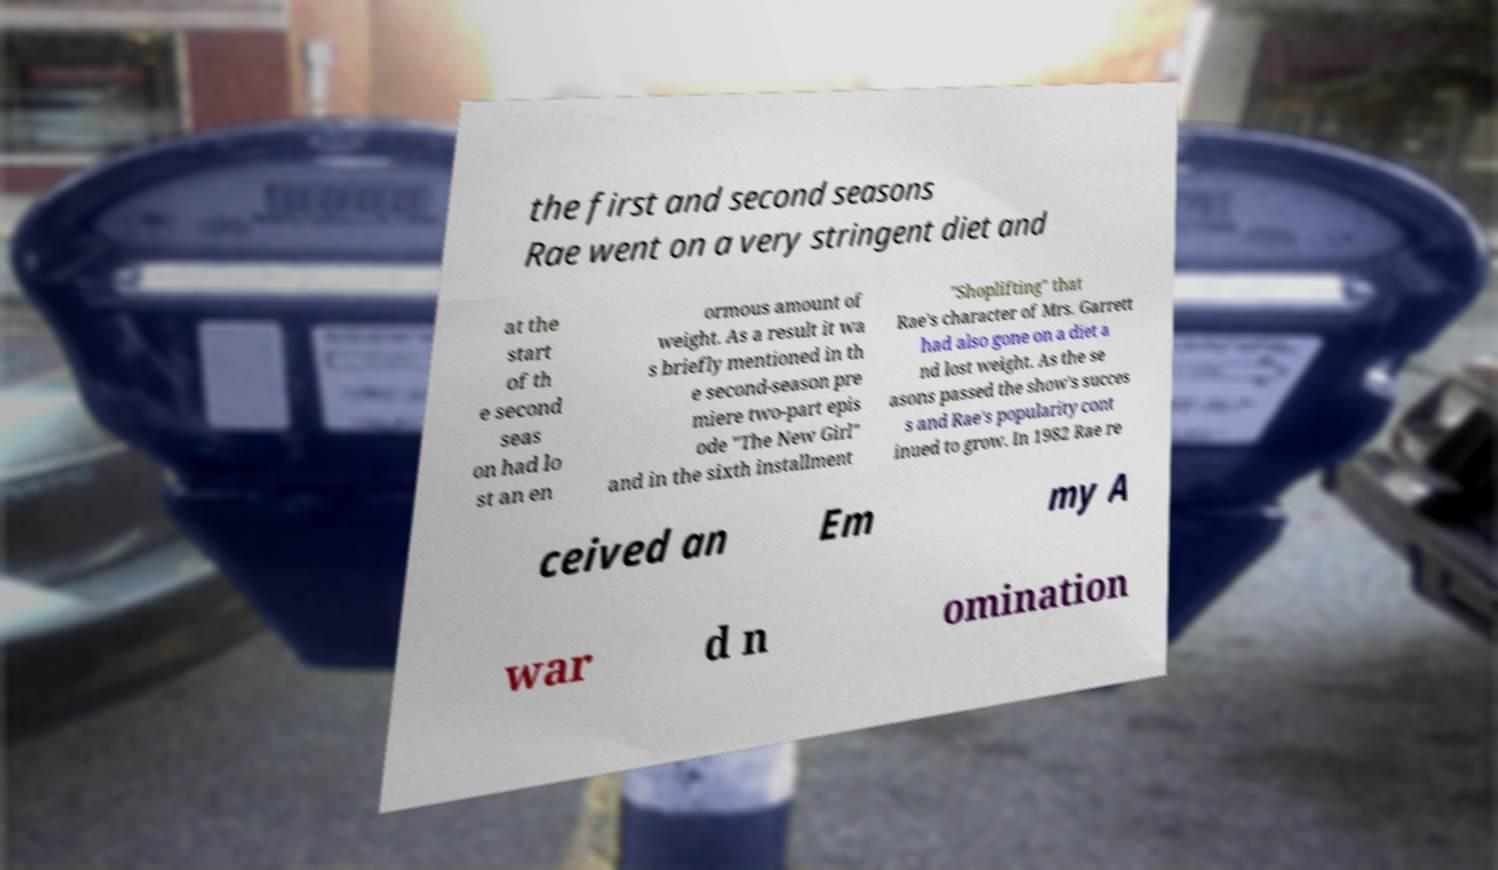What messages or text are displayed in this image? I need them in a readable, typed format. the first and second seasons Rae went on a very stringent diet and at the start of th e second seas on had lo st an en ormous amount of weight. As a result it wa s briefly mentioned in th e second-season pre miere two-part epis ode "The New Girl" and in the sixth installment "Shoplifting" that Rae's character of Mrs. Garrett had also gone on a diet a nd lost weight. As the se asons passed the show's succes s and Rae's popularity cont inued to grow. In 1982 Rae re ceived an Em my A war d n omination 